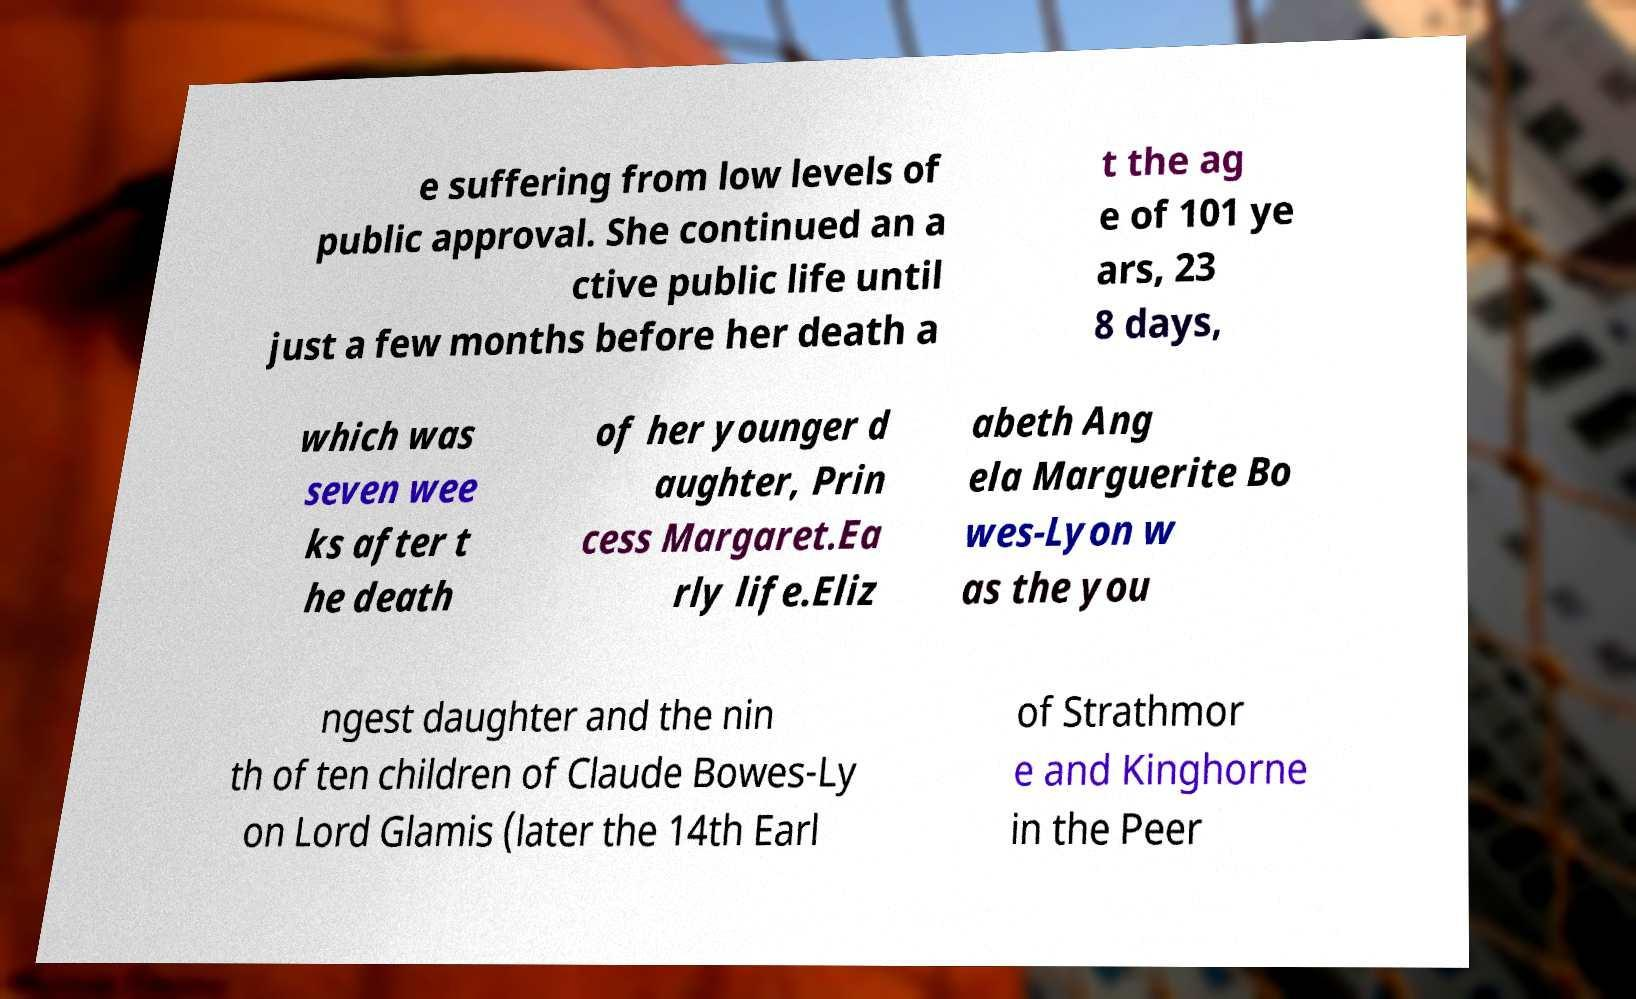Could you extract and type out the text from this image? e suffering from low levels of public approval. She continued an a ctive public life until just a few months before her death a t the ag e of 101 ye ars, 23 8 days, which was seven wee ks after t he death of her younger d aughter, Prin cess Margaret.Ea rly life.Eliz abeth Ang ela Marguerite Bo wes-Lyon w as the you ngest daughter and the nin th of ten children of Claude Bowes-Ly on Lord Glamis (later the 14th Earl of Strathmor e and Kinghorne in the Peer 